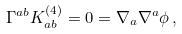Convert formula to latex. <formula><loc_0><loc_0><loc_500><loc_500>\Gamma ^ { a b } K _ { a b } ^ { ( 4 ) } = 0 = \nabla _ { a } \nabla ^ { a } \phi \, ,</formula> 